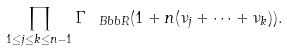<formula> <loc_0><loc_0><loc_500><loc_500>\prod _ { 1 \leq j \leq k \leq n - 1 } \Gamma _ { \ B b b { R } } ( 1 + n ( \nu _ { j } + \dots + \nu _ { k } ) ) .</formula> 